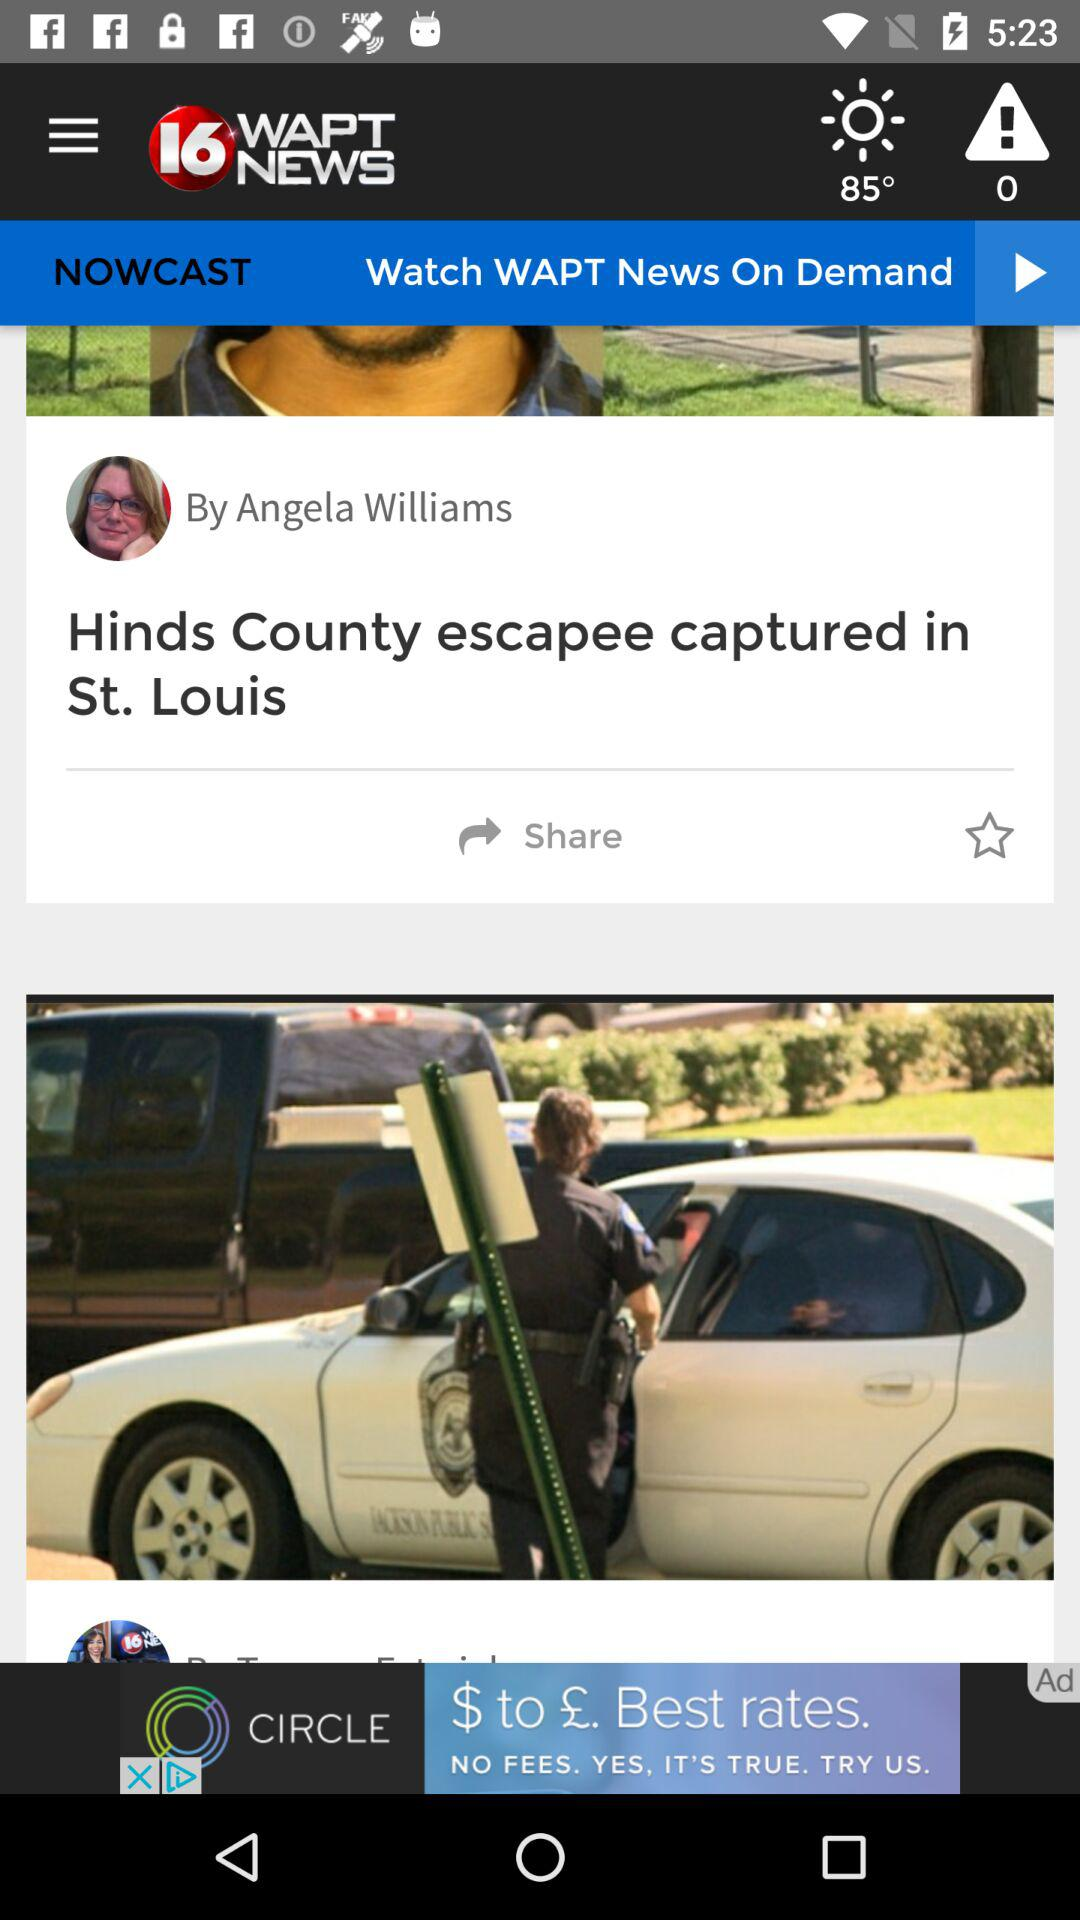What is the name of the article's author? The name of the article's author is Angela Williams. 